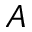<formula> <loc_0><loc_0><loc_500><loc_500>A</formula> 